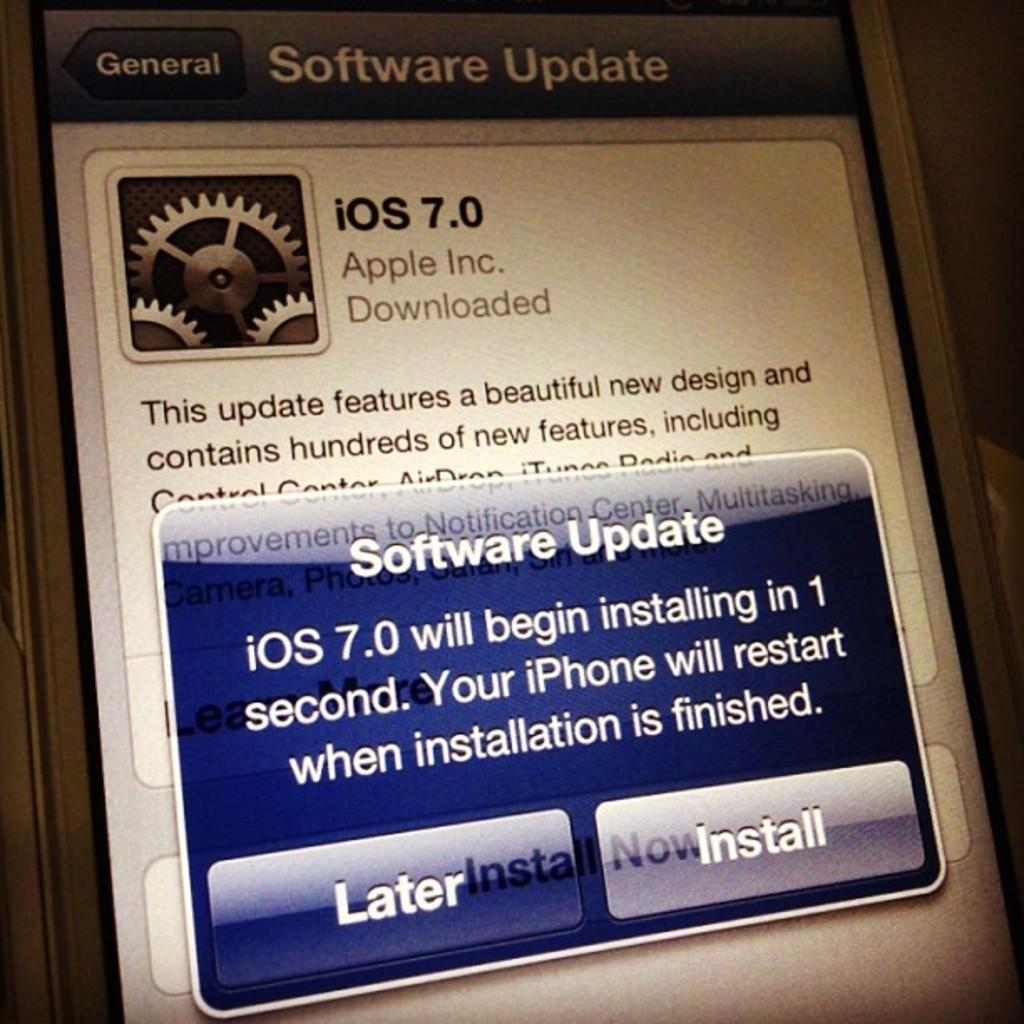Provide a one-sentence caption for the provided image. A software update screen for a ios device. 